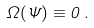<formula> <loc_0><loc_0><loc_500><loc_500>\Omega ( \Psi ) \equiv 0 \, .</formula> 